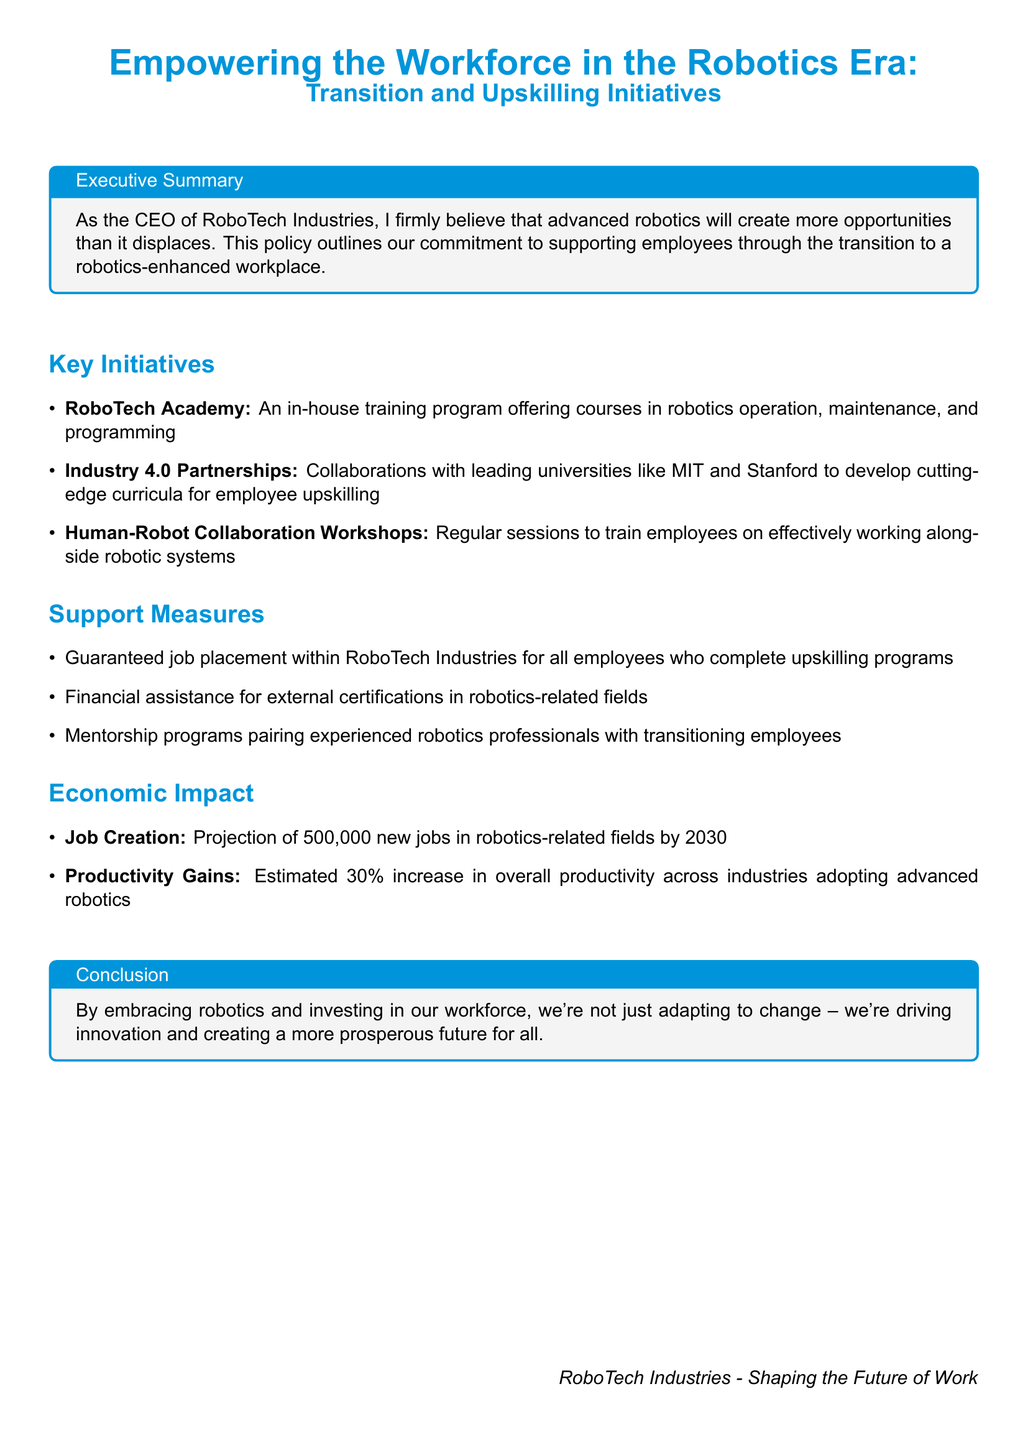What is the name of the in-house training program? The in-house training program is specifically mentioned in the document as "RoboTech Academy."
Answer: RoboTech Academy How many new jobs are projected in robotics-related fields by 2030? The document states that there is a projection of "500,000 new jobs" in robotics-related fields.
Answer: 500,000 What is the estimated increase in overall productivity across industries adopting advanced robotics? The document estimates a "30% increase" in overall productivity.
Answer: 30% What type of workshops are held regularly for employee training? The document refers to "Human-Robot Collaboration Workshops" as regular training sessions for employees.
Answer: Human-Robot Collaboration Workshops What financial support is offered for external certifications? The document mentions "financial assistance" for employees pursuing external certifications in robotics-related fields.
Answer: Financial assistance What is the conclusion of the policy document? The conclusion emphasizes the organization's commitment to embrace robotics, innovate, and create a prosperous future.
Answer: Creating a more prosperous future for all What partners does RoboTech collaborate with for developing curricula? The document mentions collaborations with leading universities like "MIT and Stanford."
Answer: MIT and Stanford What support measures guarantee job placement? The document specifies that there is a "guaranteed job placement" for employees completing upskilling programs.
Answer: Guaranteed job placement 